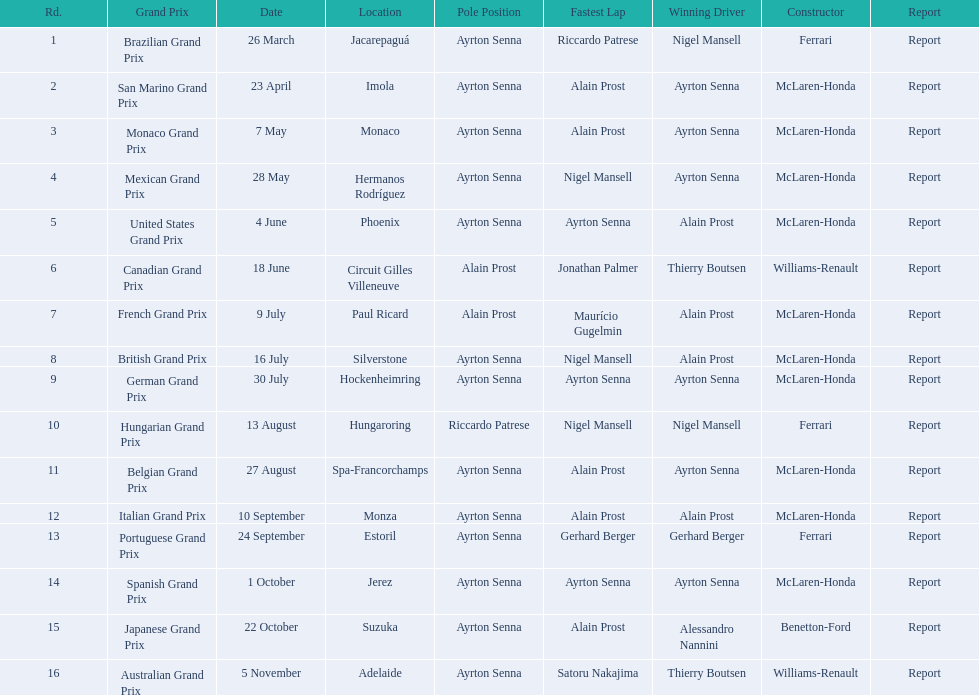Who are the constructors in the 1989 formula one season? Ferrari, McLaren-Honda, McLaren-Honda, McLaren-Honda, McLaren-Honda, Williams-Renault, McLaren-Honda, McLaren-Honda, McLaren-Honda, Ferrari, McLaren-Honda, McLaren-Honda, Ferrari, McLaren-Honda, Benetton-Ford, Williams-Renault. On what date was bennington ford the constructor? 22 October. Can you give me this table as a dict? {'header': ['Rd.', 'Grand Prix', 'Date', 'Location', 'Pole Position', 'Fastest Lap', 'Winning Driver', 'Constructor', 'Report'], 'rows': [['1', 'Brazilian Grand Prix', '26 March', 'Jacarepaguá', 'Ayrton Senna', 'Riccardo Patrese', 'Nigel Mansell', 'Ferrari', 'Report'], ['2', 'San Marino Grand Prix', '23 April', 'Imola', 'Ayrton Senna', 'Alain Prost', 'Ayrton Senna', 'McLaren-Honda', 'Report'], ['3', 'Monaco Grand Prix', '7 May', 'Monaco', 'Ayrton Senna', 'Alain Prost', 'Ayrton Senna', 'McLaren-Honda', 'Report'], ['4', 'Mexican Grand Prix', '28 May', 'Hermanos Rodríguez', 'Ayrton Senna', 'Nigel Mansell', 'Ayrton Senna', 'McLaren-Honda', 'Report'], ['5', 'United States Grand Prix', '4 June', 'Phoenix', 'Ayrton Senna', 'Ayrton Senna', 'Alain Prost', 'McLaren-Honda', 'Report'], ['6', 'Canadian Grand Prix', '18 June', 'Circuit Gilles Villeneuve', 'Alain Prost', 'Jonathan Palmer', 'Thierry Boutsen', 'Williams-Renault', 'Report'], ['7', 'French Grand Prix', '9 July', 'Paul Ricard', 'Alain Prost', 'Maurício Gugelmin', 'Alain Prost', 'McLaren-Honda', 'Report'], ['8', 'British Grand Prix', '16 July', 'Silverstone', 'Ayrton Senna', 'Nigel Mansell', 'Alain Prost', 'McLaren-Honda', 'Report'], ['9', 'German Grand Prix', '30 July', 'Hockenheimring', 'Ayrton Senna', 'Ayrton Senna', 'Ayrton Senna', 'McLaren-Honda', 'Report'], ['10', 'Hungarian Grand Prix', '13 August', 'Hungaroring', 'Riccardo Patrese', 'Nigel Mansell', 'Nigel Mansell', 'Ferrari', 'Report'], ['11', 'Belgian Grand Prix', '27 August', 'Spa-Francorchamps', 'Ayrton Senna', 'Alain Prost', 'Ayrton Senna', 'McLaren-Honda', 'Report'], ['12', 'Italian Grand Prix', '10 September', 'Monza', 'Ayrton Senna', 'Alain Prost', 'Alain Prost', 'McLaren-Honda', 'Report'], ['13', 'Portuguese Grand Prix', '24 September', 'Estoril', 'Ayrton Senna', 'Gerhard Berger', 'Gerhard Berger', 'Ferrari', 'Report'], ['14', 'Spanish Grand Prix', '1 October', 'Jerez', 'Ayrton Senna', 'Ayrton Senna', 'Ayrton Senna', 'McLaren-Honda', 'Report'], ['15', 'Japanese Grand Prix', '22 October', 'Suzuka', 'Ayrton Senna', 'Alain Prost', 'Alessandro Nannini', 'Benetton-Ford', 'Report'], ['16', 'Australian Grand Prix', '5 November', 'Adelaide', 'Ayrton Senna', 'Satoru Nakajima', 'Thierry Boutsen', 'Williams-Renault', 'Report']]} What was the race on october 22? Japanese Grand Prix. 